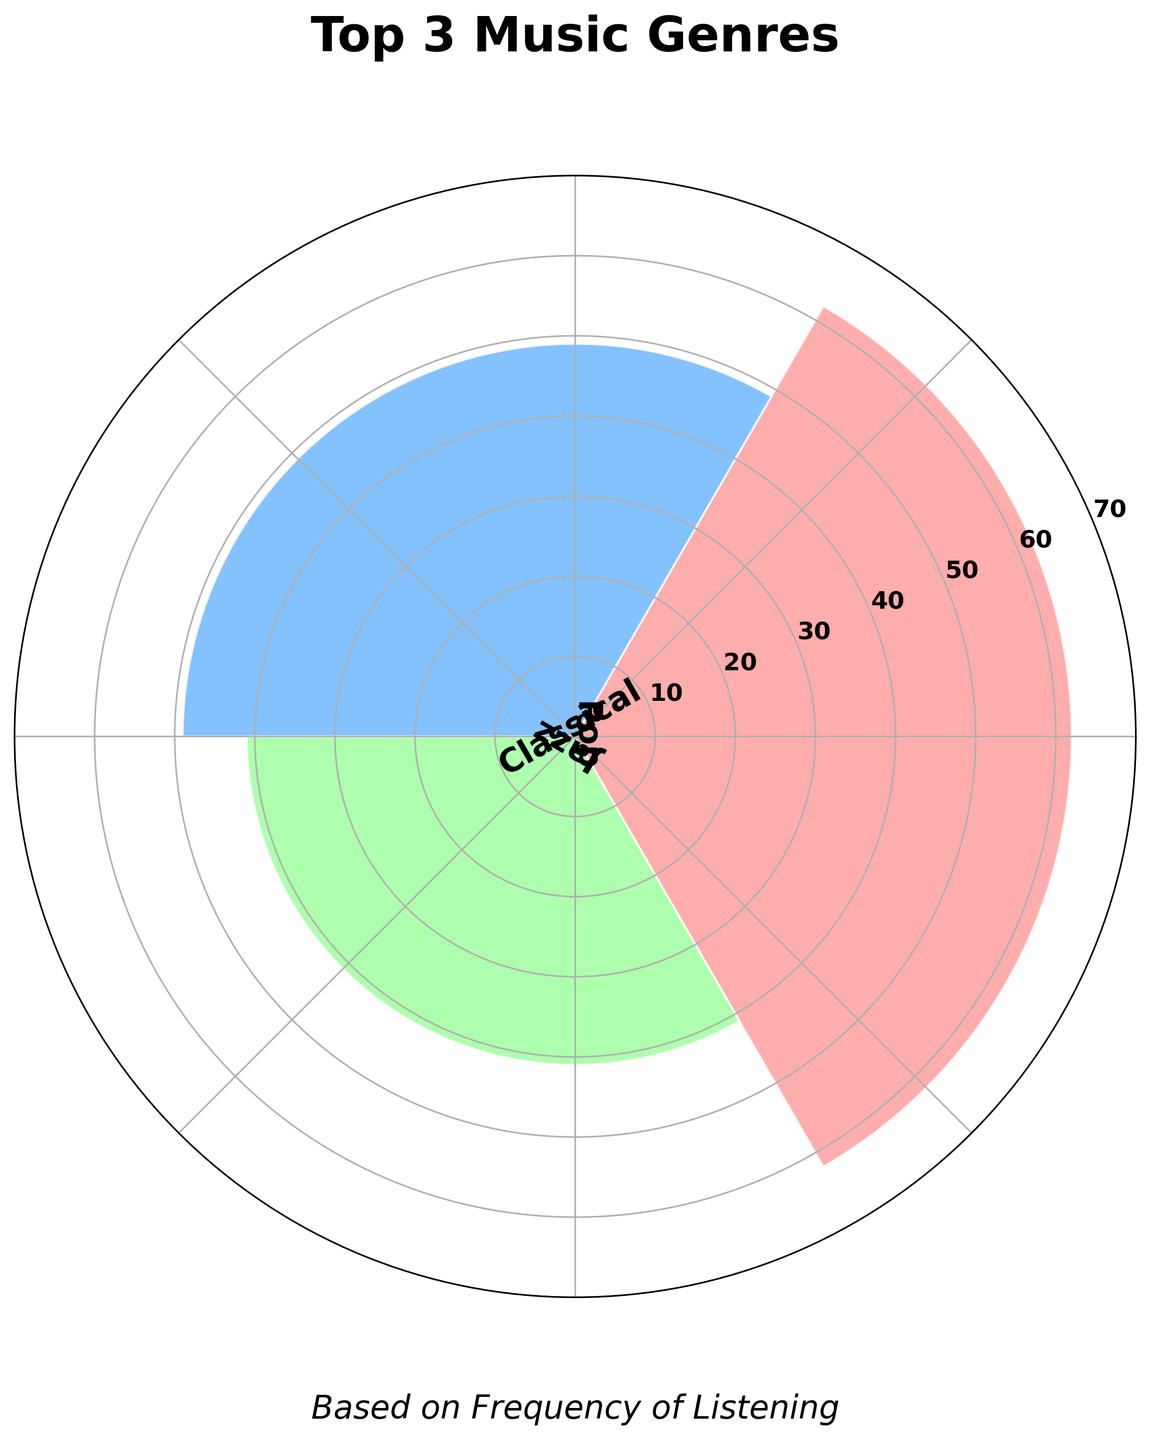What is the title of the figure? The title of the figure is located at the top and clearly states what the figure represents. In this case, the title is "Top 3 Music Genres."
Answer: Top 3 Music Genres How many genres are displayed in the rose chart? By counting the separate labeled sections around the polar plot, one can see there are 3 genres displayed.
Answer: 3 Which genre has the highest frequency? The genre with the longest bar extending from the center of the chart represents the highest frequency. In the chart, Pop has the longest bar.
Answer: Pop What are the colors of the bars representing each genre? The colors can be observed from the bars: one color for each genre. The colors are red-pink for Classical, blue for Jazz, and green for Pop.
Answer: Red-Pink (Classical), Blue (Jazz), Green (Pop) What is the total combined frequency of all displayed genres? Adding the frequencies of the genres shown on the chart (Classical, Jazz, Pop) is necessary. Classical: 49, Jazz: 41, Pop: 62. The total combined frequency is 49 + 41 + 62 = 152.
Answer: 152 How does the frequency of Jazz compare to that of Classical? By comparing the lengths of the corresponding bars, Jazz has a shorter bar than Classical. This indicates Jazz has a lower frequency.
Answer: Jazz has a lower frequency than Classical By how much does the frequency of Pop exceed the frequency of Jazz? The frequency of Pop is 62 and Jazz is 41. The difference between them is 62 - 41 = 21.
Answer: By 21 Which genre has the shortest bar? The genre with the shortest bar is Jazz, indicating it has the lowest frequency among the displayed genres.
Answer: Jazz Are there any radial labels displayed on the chart? Observing the chart, it can be noted that there are no radial labels marked around the edge of the chart.
Answer: No Where are the genre labels positioned relative to the bars? The genre labels are outside the bars, positioned around the perimeter of the circle to make them easily identifiable.
Answer: Around the perimeter of the circle 